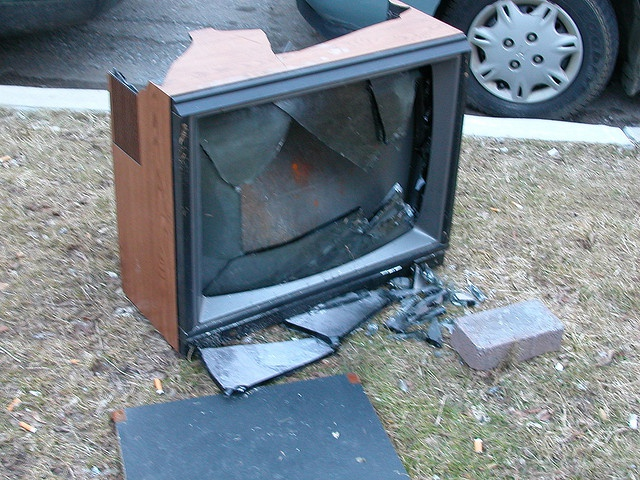Describe the objects in this image and their specific colors. I can see tv in darkblue, blue, gray, black, and brown tones and car in darkblue, black, navy, blue, and lightblue tones in this image. 